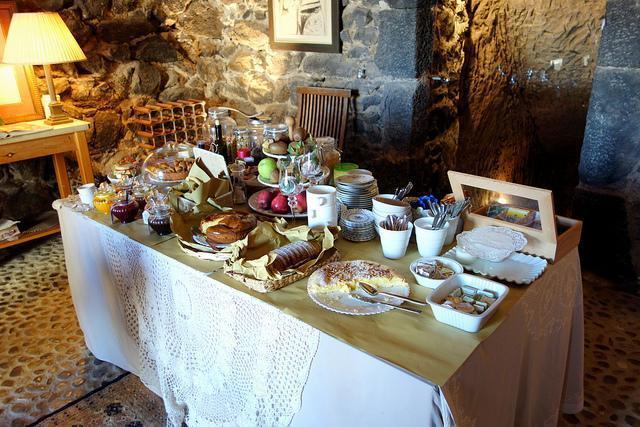How many dining tables are in the picture?
Give a very brief answer. 1. How many sheep are facing forward?
Give a very brief answer. 0. 